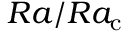Convert formula to latex. <formula><loc_0><loc_0><loc_500><loc_500>R a / R a _ { \mathrm c }</formula> 